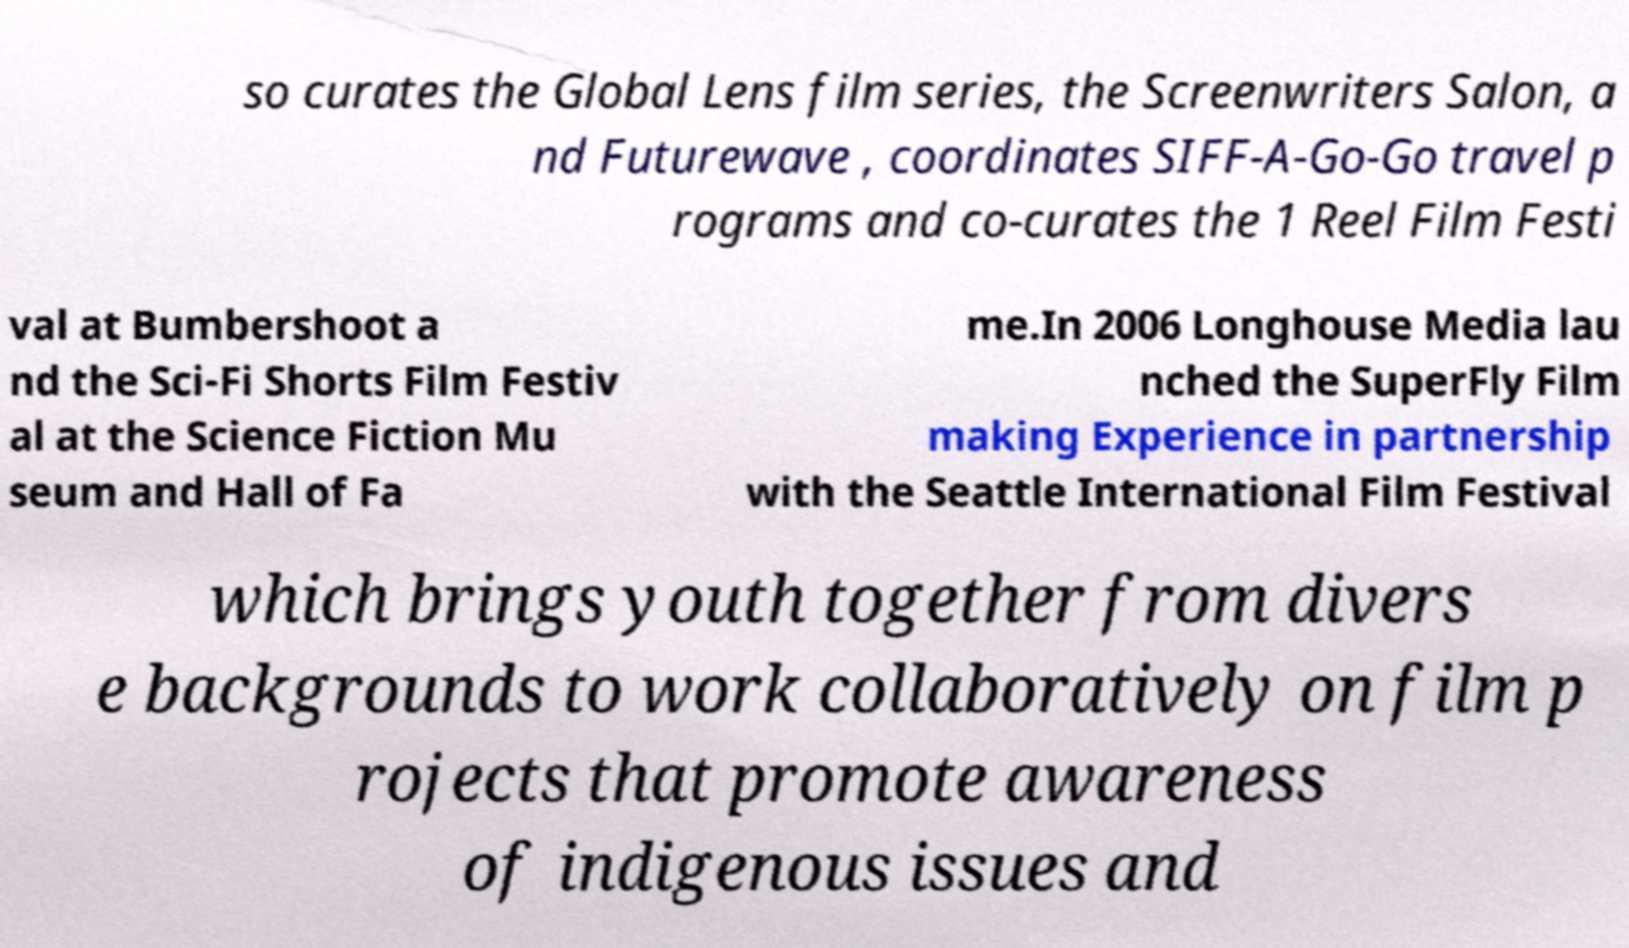Can you accurately transcribe the text from the provided image for me? so curates the Global Lens film series, the Screenwriters Salon, a nd Futurewave , coordinates SIFF-A-Go-Go travel p rograms and co-curates the 1 Reel Film Festi val at Bumbershoot a nd the Sci-Fi Shorts Film Festiv al at the Science Fiction Mu seum and Hall of Fa me.In 2006 Longhouse Media lau nched the SuperFly Film making Experience in partnership with the Seattle International Film Festival which brings youth together from divers e backgrounds to work collaboratively on film p rojects that promote awareness of indigenous issues and 